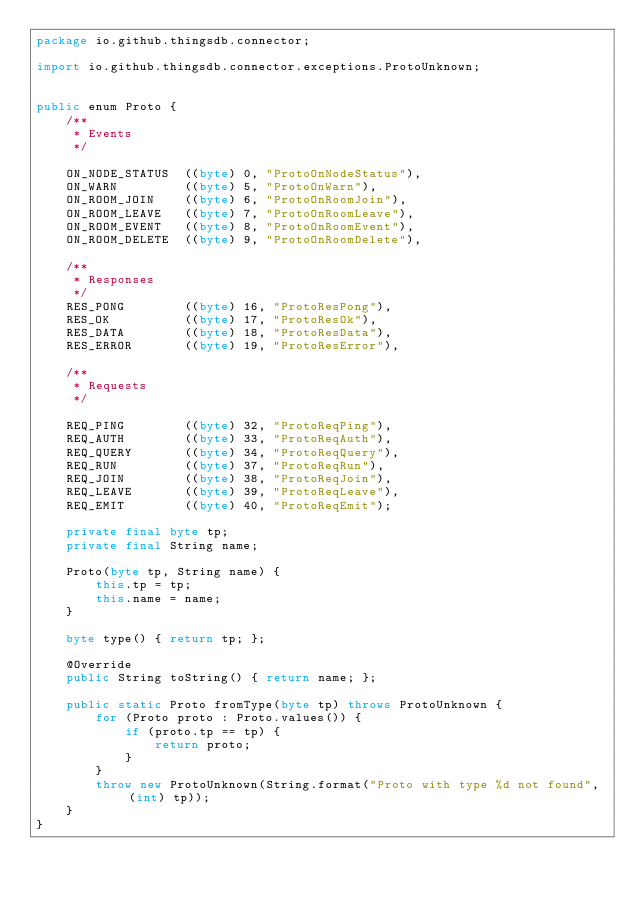Convert code to text. <code><loc_0><loc_0><loc_500><loc_500><_Java_>package io.github.thingsdb.connector;

import io.github.thingsdb.connector.exceptions.ProtoUnknown;


public enum Proto {
	/**
	 * Events
	 */

    ON_NODE_STATUS  ((byte) 0, "ProtoOnNodeStatus"),
    ON_WARN         ((byte) 5, "ProtoOnWarn"),
    ON_ROOM_JOIN    ((byte) 6, "ProtoOnRoomJoin"),
    ON_ROOM_LEAVE   ((byte) 7, "ProtoOnRoomLeave"),
    ON_ROOM_EVENT   ((byte) 8, "ProtoOnRoomEvent"),
    ON_ROOM_DELETE  ((byte) 9, "ProtoOnRoomDelete"),

	/**
	 * Responses
	 */
    RES_PONG        ((byte) 16, "ProtoResPong"),
    RES_OK          ((byte) 17, "ProtoResOk"),
    RES_DATA        ((byte) 18, "ProtoResData"),
    RES_ERROR       ((byte) 19, "ProtoResError"),

	/**
	 * Requests
	 */

    REQ_PING        ((byte) 32, "ProtoReqPing"),
    REQ_AUTH        ((byte) 33, "ProtoReqAuth"),
    REQ_QUERY       ((byte) 34, "ProtoReqQuery"),
    REQ_RUN         ((byte) 37, "ProtoReqRun"),
    REQ_JOIN        ((byte) 38, "ProtoReqJoin"),
    REQ_LEAVE       ((byte) 39, "ProtoReqLeave"),
    REQ_EMIT        ((byte) 40, "ProtoReqEmit");

    private final byte tp;
    private final String name;

    Proto(byte tp, String name) {
        this.tp = tp;
        this.name = name;
    }

    byte type() { return tp; };

    @Override
    public String toString() { return name; };

    public static Proto fromType(byte tp) throws ProtoUnknown {
        for (Proto proto : Proto.values()) {
            if (proto.tp == tp) {
                return proto;
            }
        }
        throw new ProtoUnknown(String.format("Proto with type %d not found", (int) tp));
    }
}
</code> 